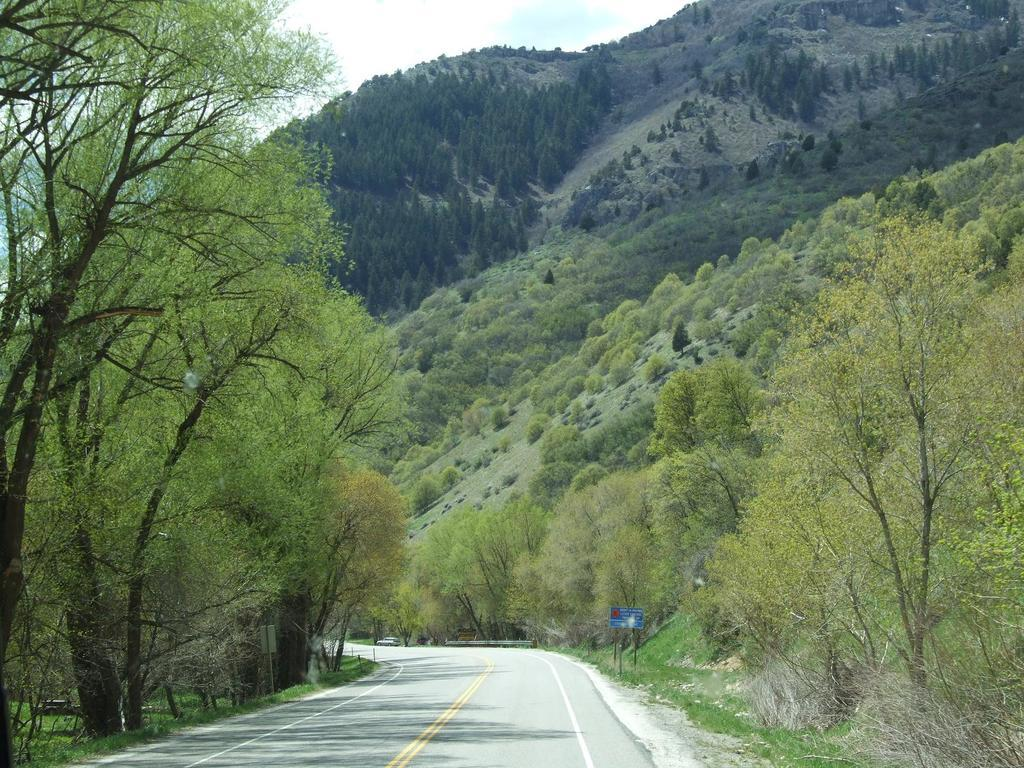What is the main feature of the image? There is a road in the image. What can be seen on either side of the road? There are trees on either side of the road. What is visible in the background of the image? There is a mountain in the background of the image. Are there any trees on the mountain? Yes, there are trees on the mountain. What color is the crayon used to draw the mountain in the image? There is no crayon present in the image; it is a photograph or illustration of a real mountain. What type of flesh can be seen on the trees in the image? There is no flesh present in the image; it is a representation of trees, which are made of wood and leaves. 